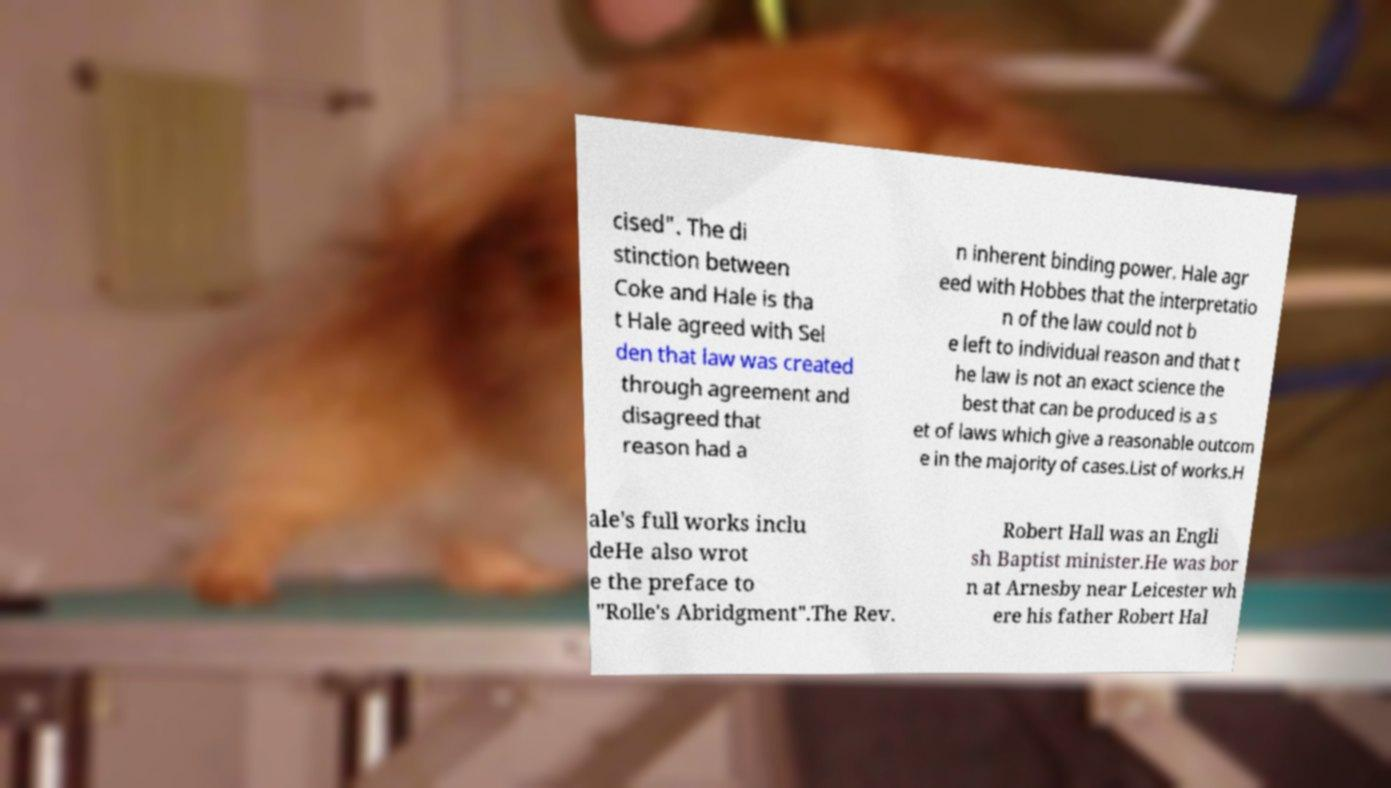Can you accurately transcribe the text from the provided image for me? cised". The di stinction between Coke and Hale is tha t Hale agreed with Sel den that law was created through agreement and disagreed that reason had a n inherent binding power. Hale agr eed with Hobbes that the interpretatio n of the law could not b e left to individual reason and that t he law is not an exact science the best that can be produced is a s et of laws which give a reasonable outcom e in the majority of cases.List of works.H ale's full works inclu deHe also wrot e the preface to "Rolle's Abridgment".The Rev. Robert Hall was an Engli sh Baptist minister.He was bor n at Arnesby near Leicester wh ere his father Robert Hal 